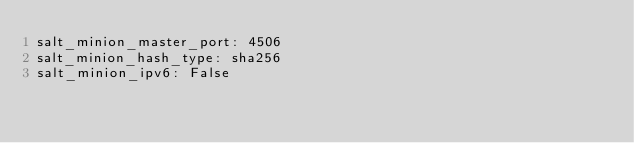Convert code to text. <code><loc_0><loc_0><loc_500><loc_500><_YAML_>salt_minion_master_port: 4506
salt_minion_hash_type: sha256
salt_minion_ipv6: False
</code> 